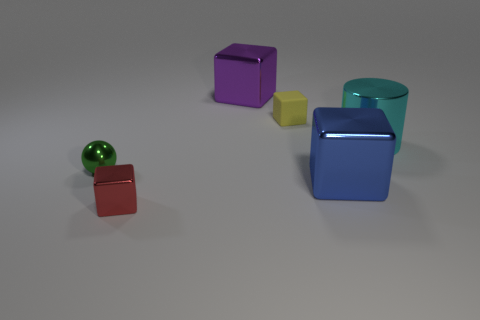Subtract all small yellow cubes. How many cubes are left? 3 Add 1 big blue shiny blocks. How many objects exist? 7 Subtract all yellow blocks. How many blocks are left? 3 Subtract 1 spheres. How many spheres are left? 0 Add 4 tiny shiny things. How many tiny shiny things exist? 6 Subtract 1 blue cubes. How many objects are left? 5 Subtract all blocks. How many objects are left? 2 Subtract all cyan balls. Subtract all brown blocks. How many balls are left? 1 Subtract all purple cylinders. How many purple blocks are left? 1 Subtract all purple metallic things. Subtract all yellow shiny objects. How many objects are left? 5 